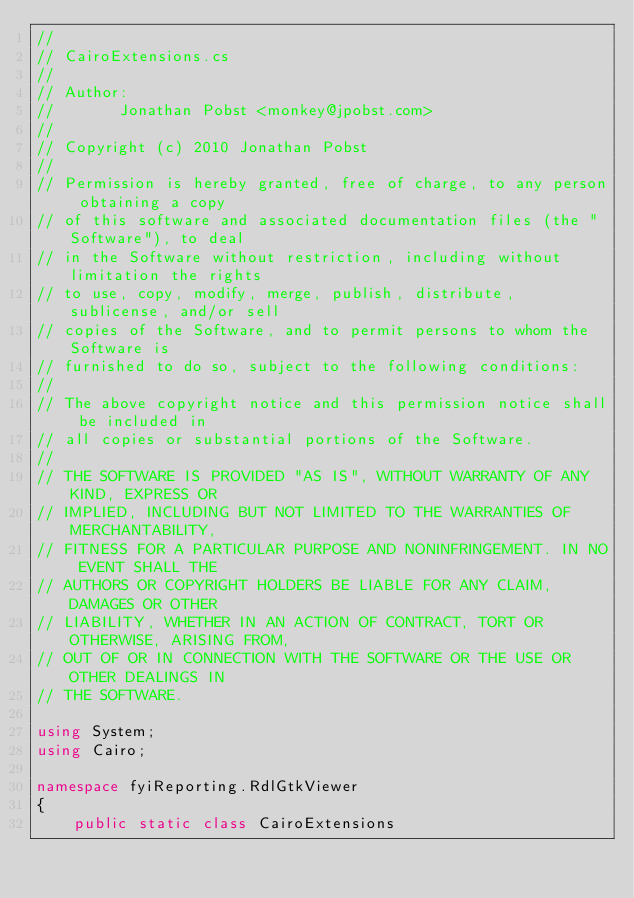Convert code to text. <code><loc_0><loc_0><loc_500><loc_500><_C#_>// 
// CairoExtensions.cs
//  
// Author:
//       Jonathan Pobst <monkey@jpobst.com>
// 
// Copyright (c) 2010 Jonathan Pobst
// 
// Permission is hereby granted, free of charge, to any person obtaining a copy
// of this software and associated documentation files (the "Software"), to deal
// in the Software without restriction, including without limitation the rights
// to use, copy, modify, merge, publish, distribute, sublicense, and/or sell
// copies of the Software, and to permit persons to whom the Software is
// furnished to do so, subject to the following conditions:
// 
// The above copyright notice and this permission notice shall be included in
// all copies or substantial portions of the Software.
// 
// THE SOFTWARE IS PROVIDED "AS IS", WITHOUT WARRANTY OF ANY KIND, EXPRESS OR
// IMPLIED, INCLUDING BUT NOT LIMITED TO THE WARRANTIES OF MERCHANTABILITY,
// FITNESS FOR A PARTICULAR PURPOSE AND NONINFRINGEMENT. IN NO EVENT SHALL THE
// AUTHORS OR COPYRIGHT HOLDERS BE LIABLE FOR ANY CLAIM, DAMAGES OR OTHER
// LIABILITY, WHETHER IN AN ACTION OF CONTRACT, TORT OR OTHERWISE, ARISING FROM,
// OUT OF OR IN CONNECTION WITH THE SOFTWARE OR THE USE OR OTHER DEALINGS IN
// THE SOFTWARE.

using System;
using Cairo;

namespace fyiReporting.RdlGtkViewer
{
	public static class CairoExtensions</code> 